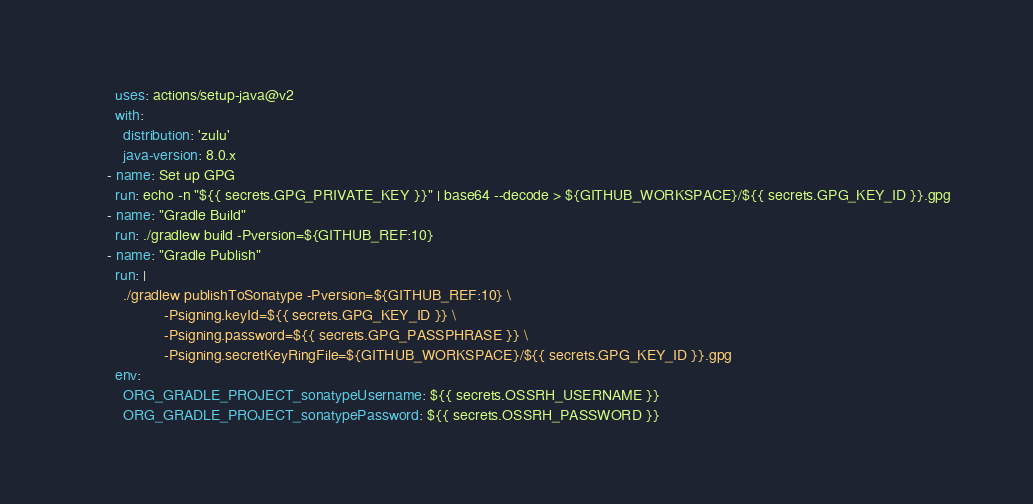Convert code to text. <code><loc_0><loc_0><loc_500><loc_500><_YAML_>        uses: actions/setup-java@v2
        with:
          distribution: 'zulu'
          java-version: 8.0.x
      - name: Set up GPG
        run: echo -n "${{ secrets.GPG_PRIVATE_KEY }}" | base64 --decode > ${GITHUB_WORKSPACE}/${{ secrets.GPG_KEY_ID }}.gpg
      - name: "Gradle Build"
        run: ./gradlew build -Pversion=${GITHUB_REF:10}
      - name: "Gradle Publish"
        run: |
          ./gradlew publishToSonatype -Pversion=${GITHUB_REF:10} \
                    -Psigning.keyId=${{ secrets.GPG_KEY_ID }} \
                    -Psigning.password=${{ secrets.GPG_PASSPHRASE }} \
                    -Psigning.secretKeyRingFile=${GITHUB_WORKSPACE}/${{ secrets.GPG_KEY_ID }}.gpg
        env:
          ORG_GRADLE_PROJECT_sonatypeUsername: ${{ secrets.OSSRH_USERNAME }}
          ORG_GRADLE_PROJECT_sonatypePassword: ${{ secrets.OSSRH_PASSWORD }}
</code> 